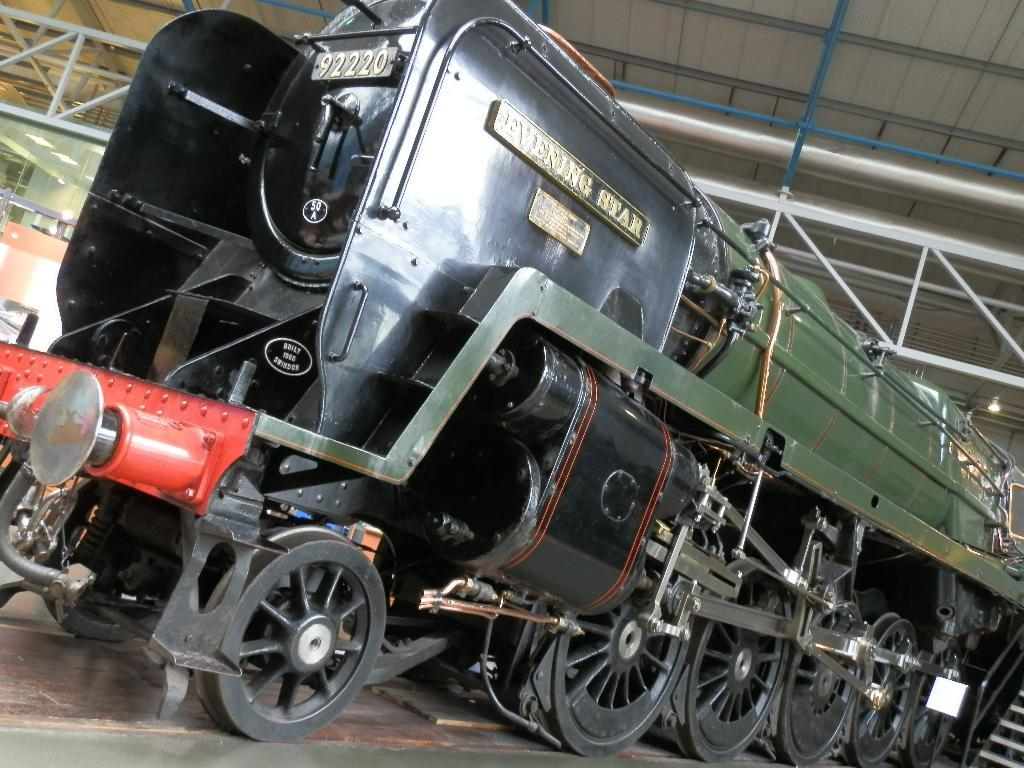What mode of transportation can be seen in the image? There is a train on a platform in the image. What architectural feature is present in the image? There are steps in the image. What can be seen in the background of the image? There are rods, lights, and other objects visible in the background of the image. What type of pie is being served to the goldfish in the image? There is no pie or goldfish present in the image. 